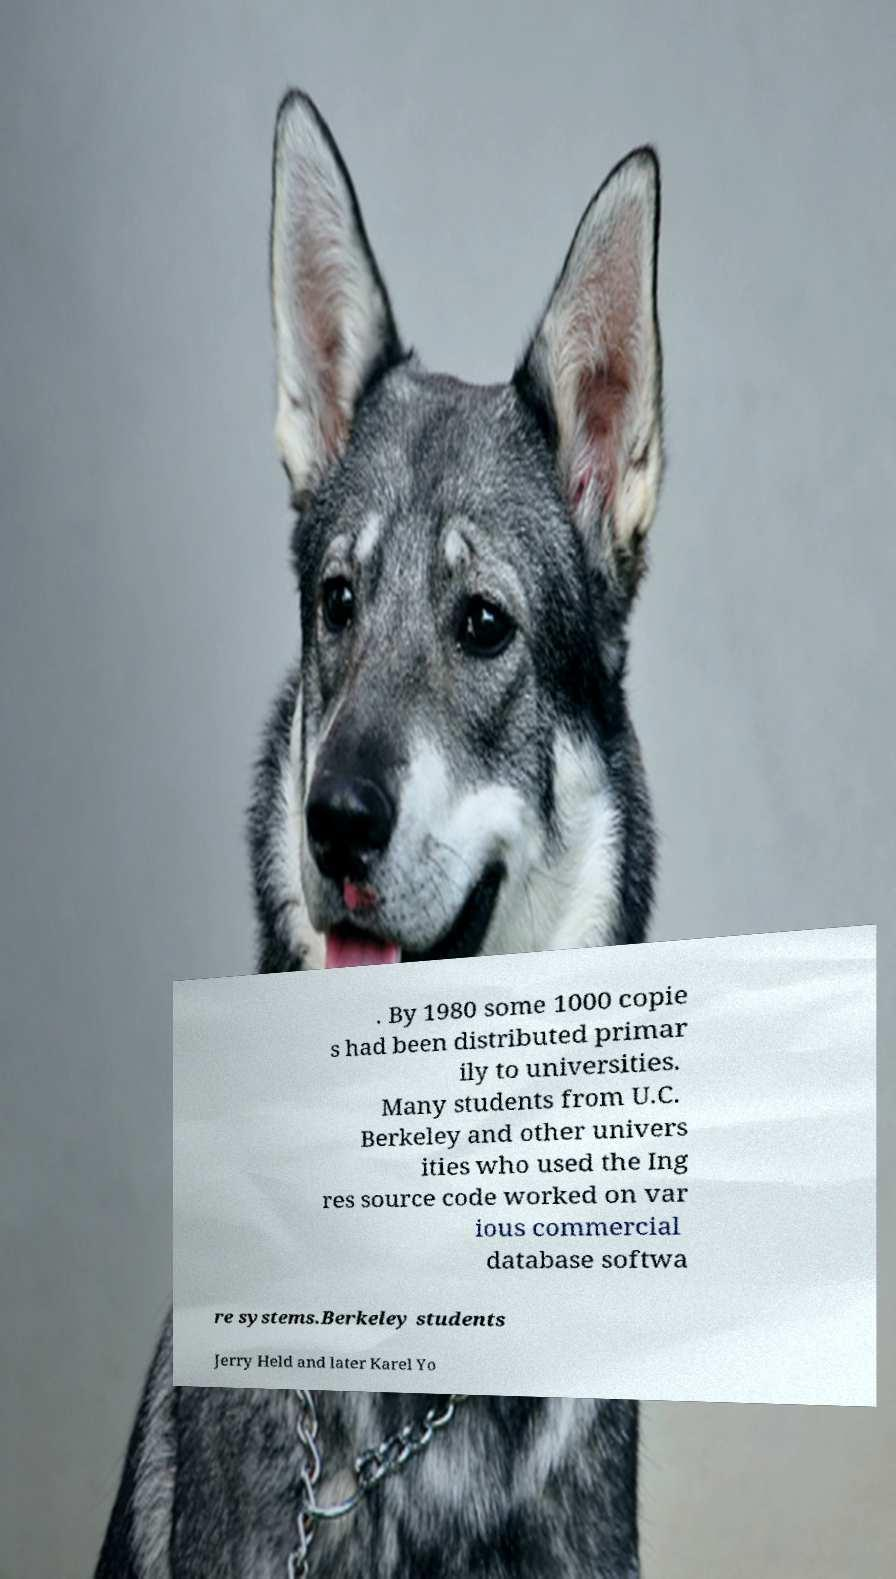What messages or text are displayed in this image? I need them in a readable, typed format. . By 1980 some 1000 copie s had been distributed primar ily to universities. Many students from U.C. Berkeley and other univers ities who used the Ing res source code worked on var ious commercial database softwa re systems.Berkeley students Jerry Held and later Karel Yo 